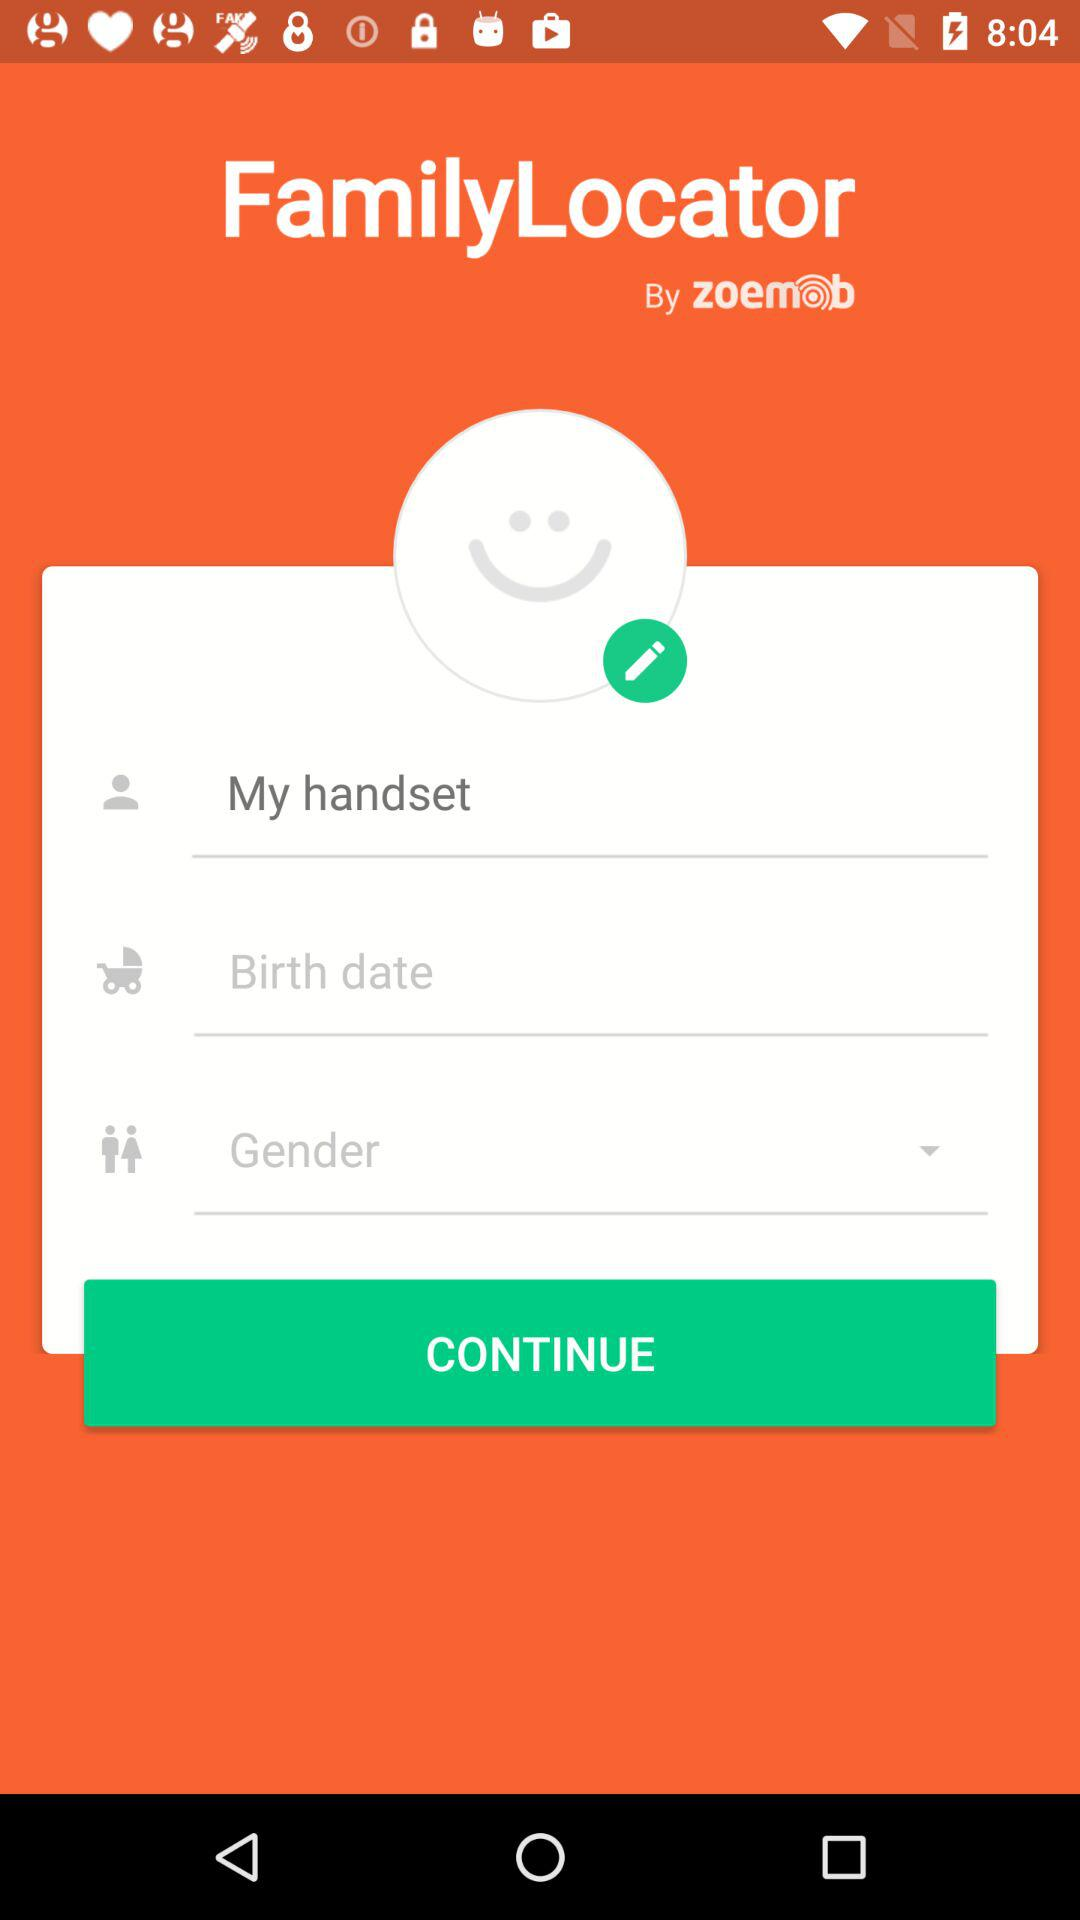What is the application name? The application name is "FamilyLocator". 